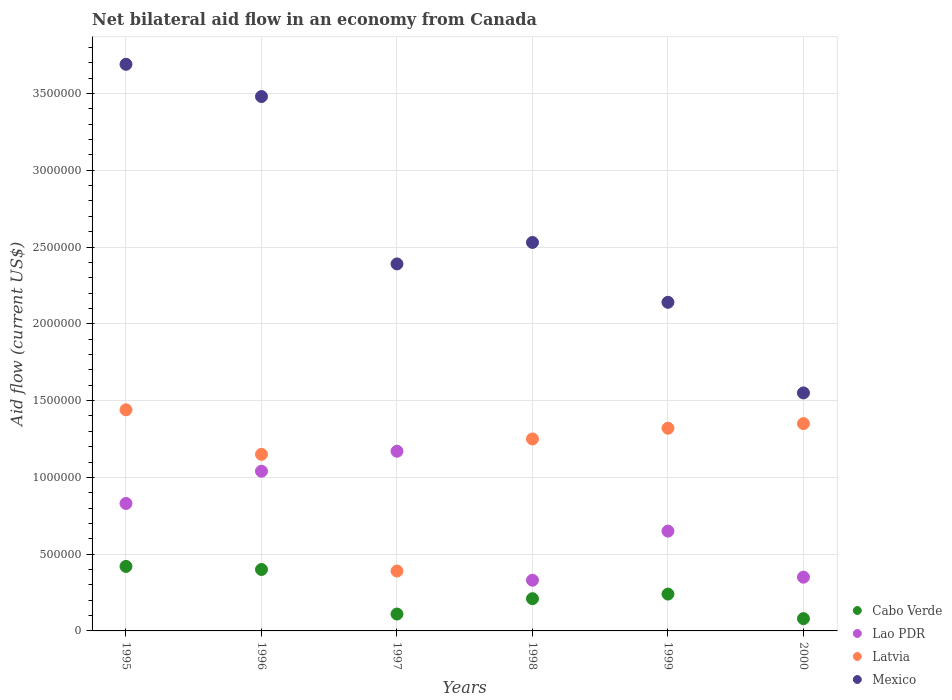How many different coloured dotlines are there?
Your answer should be very brief. 4. What is the net bilateral aid flow in Latvia in 1999?
Provide a short and direct response. 1.32e+06. Across all years, what is the maximum net bilateral aid flow in Latvia?
Give a very brief answer. 1.44e+06. What is the total net bilateral aid flow in Cabo Verde in the graph?
Your answer should be compact. 1.46e+06. What is the difference between the net bilateral aid flow in Latvia in 1996 and that in 1998?
Keep it short and to the point. -1.00e+05. What is the difference between the net bilateral aid flow in Mexico in 1995 and the net bilateral aid flow in Latvia in 2000?
Offer a terse response. 2.34e+06. What is the average net bilateral aid flow in Mexico per year?
Make the answer very short. 2.63e+06. In the year 1996, what is the difference between the net bilateral aid flow in Mexico and net bilateral aid flow in Cabo Verde?
Keep it short and to the point. 3.08e+06. In how many years, is the net bilateral aid flow in Mexico greater than 1300000 US$?
Provide a short and direct response. 6. What is the ratio of the net bilateral aid flow in Cabo Verde in 1997 to that in 1999?
Offer a terse response. 0.46. Is the net bilateral aid flow in Cabo Verde in 1997 less than that in 1999?
Keep it short and to the point. Yes. What is the difference between the highest and the second highest net bilateral aid flow in Mexico?
Give a very brief answer. 2.10e+05. What is the difference between the highest and the lowest net bilateral aid flow in Mexico?
Make the answer very short. 2.14e+06. Is the sum of the net bilateral aid flow in Cabo Verde in 1995 and 2000 greater than the maximum net bilateral aid flow in Lao PDR across all years?
Make the answer very short. No. Is it the case that in every year, the sum of the net bilateral aid flow in Latvia and net bilateral aid flow in Mexico  is greater than the net bilateral aid flow in Lao PDR?
Offer a very short reply. Yes. Does the net bilateral aid flow in Cabo Verde monotonically increase over the years?
Provide a succinct answer. No. Is the net bilateral aid flow in Cabo Verde strictly greater than the net bilateral aid flow in Mexico over the years?
Keep it short and to the point. No. How many dotlines are there?
Ensure brevity in your answer.  4. What is the difference between two consecutive major ticks on the Y-axis?
Provide a short and direct response. 5.00e+05. How many legend labels are there?
Give a very brief answer. 4. What is the title of the graph?
Give a very brief answer. Net bilateral aid flow in an economy from Canada. Does "Myanmar" appear as one of the legend labels in the graph?
Provide a short and direct response. No. What is the Aid flow (current US$) of Cabo Verde in 1995?
Ensure brevity in your answer.  4.20e+05. What is the Aid flow (current US$) of Lao PDR in 1995?
Your answer should be very brief. 8.30e+05. What is the Aid flow (current US$) of Latvia in 1995?
Provide a short and direct response. 1.44e+06. What is the Aid flow (current US$) in Mexico in 1995?
Your answer should be very brief. 3.69e+06. What is the Aid flow (current US$) of Cabo Verde in 1996?
Your response must be concise. 4.00e+05. What is the Aid flow (current US$) of Lao PDR in 1996?
Your response must be concise. 1.04e+06. What is the Aid flow (current US$) in Latvia in 1996?
Ensure brevity in your answer.  1.15e+06. What is the Aid flow (current US$) in Mexico in 1996?
Provide a succinct answer. 3.48e+06. What is the Aid flow (current US$) in Lao PDR in 1997?
Your response must be concise. 1.17e+06. What is the Aid flow (current US$) in Latvia in 1997?
Give a very brief answer. 3.90e+05. What is the Aid flow (current US$) of Mexico in 1997?
Your answer should be compact. 2.39e+06. What is the Aid flow (current US$) of Latvia in 1998?
Your answer should be very brief. 1.25e+06. What is the Aid flow (current US$) in Mexico in 1998?
Your answer should be very brief. 2.53e+06. What is the Aid flow (current US$) in Lao PDR in 1999?
Offer a very short reply. 6.50e+05. What is the Aid flow (current US$) of Latvia in 1999?
Provide a short and direct response. 1.32e+06. What is the Aid flow (current US$) in Mexico in 1999?
Offer a very short reply. 2.14e+06. What is the Aid flow (current US$) of Latvia in 2000?
Your answer should be compact. 1.35e+06. What is the Aid flow (current US$) of Mexico in 2000?
Your answer should be compact. 1.55e+06. Across all years, what is the maximum Aid flow (current US$) of Cabo Verde?
Your response must be concise. 4.20e+05. Across all years, what is the maximum Aid flow (current US$) of Lao PDR?
Provide a short and direct response. 1.17e+06. Across all years, what is the maximum Aid flow (current US$) of Latvia?
Keep it short and to the point. 1.44e+06. Across all years, what is the maximum Aid flow (current US$) of Mexico?
Offer a very short reply. 3.69e+06. Across all years, what is the minimum Aid flow (current US$) in Lao PDR?
Your response must be concise. 3.30e+05. Across all years, what is the minimum Aid flow (current US$) of Latvia?
Your answer should be very brief. 3.90e+05. Across all years, what is the minimum Aid flow (current US$) in Mexico?
Make the answer very short. 1.55e+06. What is the total Aid flow (current US$) of Cabo Verde in the graph?
Give a very brief answer. 1.46e+06. What is the total Aid flow (current US$) of Lao PDR in the graph?
Your answer should be compact. 4.37e+06. What is the total Aid flow (current US$) of Latvia in the graph?
Provide a succinct answer. 6.90e+06. What is the total Aid flow (current US$) of Mexico in the graph?
Your answer should be compact. 1.58e+07. What is the difference between the Aid flow (current US$) in Lao PDR in 1995 and that in 1996?
Provide a short and direct response. -2.10e+05. What is the difference between the Aid flow (current US$) in Latvia in 1995 and that in 1996?
Offer a terse response. 2.90e+05. What is the difference between the Aid flow (current US$) of Lao PDR in 1995 and that in 1997?
Keep it short and to the point. -3.40e+05. What is the difference between the Aid flow (current US$) of Latvia in 1995 and that in 1997?
Your answer should be very brief. 1.05e+06. What is the difference between the Aid flow (current US$) in Mexico in 1995 and that in 1997?
Your answer should be compact. 1.30e+06. What is the difference between the Aid flow (current US$) in Latvia in 1995 and that in 1998?
Ensure brevity in your answer.  1.90e+05. What is the difference between the Aid flow (current US$) of Mexico in 1995 and that in 1998?
Ensure brevity in your answer.  1.16e+06. What is the difference between the Aid flow (current US$) in Lao PDR in 1995 and that in 1999?
Keep it short and to the point. 1.80e+05. What is the difference between the Aid flow (current US$) of Latvia in 1995 and that in 1999?
Offer a terse response. 1.20e+05. What is the difference between the Aid flow (current US$) in Mexico in 1995 and that in 1999?
Make the answer very short. 1.55e+06. What is the difference between the Aid flow (current US$) of Cabo Verde in 1995 and that in 2000?
Offer a terse response. 3.40e+05. What is the difference between the Aid flow (current US$) of Latvia in 1995 and that in 2000?
Provide a succinct answer. 9.00e+04. What is the difference between the Aid flow (current US$) of Mexico in 1995 and that in 2000?
Offer a terse response. 2.14e+06. What is the difference between the Aid flow (current US$) in Lao PDR in 1996 and that in 1997?
Keep it short and to the point. -1.30e+05. What is the difference between the Aid flow (current US$) of Latvia in 1996 and that in 1997?
Offer a terse response. 7.60e+05. What is the difference between the Aid flow (current US$) of Mexico in 1996 and that in 1997?
Give a very brief answer. 1.09e+06. What is the difference between the Aid flow (current US$) in Cabo Verde in 1996 and that in 1998?
Provide a succinct answer. 1.90e+05. What is the difference between the Aid flow (current US$) in Lao PDR in 1996 and that in 1998?
Offer a very short reply. 7.10e+05. What is the difference between the Aid flow (current US$) of Latvia in 1996 and that in 1998?
Your response must be concise. -1.00e+05. What is the difference between the Aid flow (current US$) in Mexico in 1996 and that in 1998?
Offer a terse response. 9.50e+05. What is the difference between the Aid flow (current US$) of Cabo Verde in 1996 and that in 1999?
Offer a very short reply. 1.60e+05. What is the difference between the Aid flow (current US$) in Lao PDR in 1996 and that in 1999?
Ensure brevity in your answer.  3.90e+05. What is the difference between the Aid flow (current US$) of Mexico in 1996 and that in 1999?
Your response must be concise. 1.34e+06. What is the difference between the Aid flow (current US$) in Cabo Verde in 1996 and that in 2000?
Your answer should be compact. 3.20e+05. What is the difference between the Aid flow (current US$) in Lao PDR in 1996 and that in 2000?
Offer a terse response. 6.90e+05. What is the difference between the Aid flow (current US$) of Latvia in 1996 and that in 2000?
Ensure brevity in your answer.  -2.00e+05. What is the difference between the Aid flow (current US$) of Mexico in 1996 and that in 2000?
Make the answer very short. 1.93e+06. What is the difference between the Aid flow (current US$) in Lao PDR in 1997 and that in 1998?
Your answer should be very brief. 8.40e+05. What is the difference between the Aid flow (current US$) of Latvia in 1997 and that in 1998?
Your answer should be compact. -8.60e+05. What is the difference between the Aid flow (current US$) of Mexico in 1997 and that in 1998?
Provide a succinct answer. -1.40e+05. What is the difference between the Aid flow (current US$) in Lao PDR in 1997 and that in 1999?
Provide a short and direct response. 5.20e+05. What is the difference between the Aid flow (current US$) of Latvia in 1997 and that in 1999?
Provide a short and direct response. -9.30e+05. What is the difference between the Aid flow (current US$) in Cabo Verde in 1997 and that in 2000?
Ensure brevity in your answer.  3.00e+04. What is the difference between the Aid flow (current US$) in Lao PDR in 1997 and that in 2000?
Your response must be concise. 8.20e+05. What is the difference between the Aid flow (current US$) of Latvia in 1997 and that in 2000?
Offer a terse response. -9.60e+05. What is the difference between the Aid flow (current US$) in Mexico in 1997 and that in 2000?
Your answer should be very brief. 8.40e+05. What is the difference between the Aid flow (current US$) in Lao PDR in 1998 and that in 1999?
Your answer should be very brief. -3.20e+05. What is the difference between the Aid flow (current US$) in Latvia in 1998 and that in 1999?
Offer a very short reply. -7.00e+04. What is the difference between the Aid flow (current US$) in Mexico in 1998 and that in 1999?
Keep it short and to the point. 3.90e+05. What is the difference between the Aid flow (current US$) in Cabo Verde in 1998 and that in 2000?
Ensure brevity in your answer.  1.30e+05. What is the difference between the Aid flow (current US$) of Mexico in 1998 and that in 2000?
Provide a succinct answer. 9.80e+05. What is the difference between the Aid flow (current US$) in Mexico in 1999 and that in 2000?
Offer a very short reply. 5.90e+05. What is the difference between the Aid flow (current US$) in Cabo Verde in 1995 and the Aid flow (current US$) in Lao PDR in 1996?
Make the answer very short. -6.20e+05. What is the difference between the Aid flow (current US$) in Cabo Verde in 1995 and the Aid flow (current US$) in Latvia in 1996?
Offer a very short reply. -7.30e+05. What is the difference between the Aid flow (current US$) of Cabo Verde in 1995 and the Aid flow (current US$) of Mexico in 1996?
Your answer should be very brief. -3.06e+06. What is the difference between the Aid flow (current US$) of Lao PDR in 1995 and the Aid flow (current US$) of Latvia in 1996?
Ensure brevity in your answer.  -3.20e+05. What is the difference between the Aid flow (current US$) of Lao PDR in 1995 and the Aid flow (current US$) of Mexico in 1996?
Your answer should be compact. -2.65e+06. What is the difference between the Aid flow (current US$) in Latvia in 1995 and the Aid flow (current US$) in Mexico in 1996?
Provide a short and direct response. -2.04e+06. What is the difference between the Aid flow (current US$) of Cabo Verde in 1995 and the Aid flow (current US$) of Lao PDR in 1997?
Your answer should be compact. -7.50e+05. What is the difference between the Aid flow (current US$) in Cabo Verde in 1995 and the Aid flow (current US$) in Mexico in 1997?
Make the answer very short. -1.97e+06. What is the difference between the Aid flow (current US$) of Lao PDR in 1995 and the Aid flow (current US$) of Latvia in 1997?
Offer a terse response. 4.40e+05. What is the difference between the Aid flow (current US$) of Lao PDR in 1995 and the Aid flow (current US$) of Mexico in 1997?
Offer a very short reply. -1.56e+06. What is the difference between the Aid flow (current US$) of Latvia in 1995 and the Aid flow (current US$) of Mexico in 1997?
Give a very brief answer. -9.50e+05. What is the difference between the Aid flow (current US$) in Cabo Verde in 1995 and the Aid flow (current US$) in Lao PDR in 1998?
Offer a very short reply. 9.00e+04. What is the difference between the Aid flow (current US$) in Cabo Verde in 1995 and the Aid flow (current US$) in Latvia in 1998?
Provide a short and direct response. -8.30e+05. What is the difference between the Aid flow (current US$) of Cabo Verde in 1995 and the Aid flow (current US$) of Mexico in 1998?
Your response must be concise. -2.11e+06. What is the difference between the Aid flow (current US$) in Lao PDR in 1995 and the Aid flow (current US$) in Latvia in 1998?
Provide a short and direct response. -4.20e+05. What is the difference between the Aid flow (current US$) of Lao PDR in 1995 and the Aid flow (current US$) of Mexico in 1998?
Offer a terse response. -1.70e+06. What is the difference between the Aid flow (current US$) in Latvia in 1995 and the Aid flow (current US$) in Mexico in 1998?
Give a very brief answer. -1.09e+06. What is the difference between the Aid flow (current US$) in Cabo Verde in 1995 and the Aid flow (current US$) in Latvia in 1999?
Your answer should be very brief. -9.00e+05. What is the difference between the Aid flow (current US$) in Cabo Verde in 1995 and the Aid flow (current US$) in Mexico in 1999?
Offer a terse response. -1.72e+06. What is the difference between the Aid flow (current US$) in Lao PDR in 1995 and the Aid flow (current US$) in Latvia in 1999?
Offer a terse response. -4.90e+05. What is the difference between the Aid flow (current US$) in Lao PDR in 1995 and the Aid flow (current US$) in Mexico in 1999?
Your answer should be compact. -1.31e+06. What is the difference between the Aid flow (current US$) of Latvia in 1995 and the Aid flow (current US$) of Mexico in 1999?
Your response must be concise. -7.00e+05. What is the difference between the Aid flow (current US$) in Cabo Verde in 1995 and the Aid flow (current US$) in Lao PDR in 2000?
Your response must be concise. 7.00e+04. What is the difference between the Aid flow (current US$) in Cabo Verde in 1995 and the Aid flow (current US$) in Latvia in 2000?
Your answer should be compact. -9.30e+05. What is the difference between the Aid flow (current US$) in Cabo Verde in 1995 and the Aid flow (current US$) in Mexico in 2000?
Provide a succinct answer. -1.13e+06. What is the difference between the Aid flow (current US$) in Lao PDR in 1995 and the Aid flow (current US$) in Latvia in 2000?
Provide a short and direct response. -5.20e+05. What is the difference between the Aid flow (current US$) in Lao PDR in 1995 and the Aid flow (current US$) in Mexico in 2000?
Your answer should be very brief. -7.20e+05. What is the difference between the Aid flow (current US$) in Latvia in 1995 and the Aid flow (current US$) in Mexico in 2000?
Provide a succinct answer. -1.10e+05. What is the difference between the Aid flow (current US$) of Cabo Verde in 1996 and the Aid flow (current US$) of Lao PDR in 1997?
Your response must be concise. -7.70e+05. What is the difference between the Aid flow (current US$) of Cabo Verde in 1996 and the Aid flow (current US$) of Mexico in 1997?
Your answer should be very brief. -1.99e+06. What is the difference between the Aid flow (current US$) of Lao PDR in 1996 and the Aid flow (current US$) of Latvia in 1997?
Provide a succinct answer. 6.50e+05. What is the difference between the Aid flow (current US$) in Lao PDR in 1996 and the Aid flow (current US$) in Mexico in 1997?
Give a very brief answer. -1.35e+06. What is the difference between the Aid flow (current US$) of Latvia in 1996 and the Aid flow (current US$) of Mexico in 1997?
Provide a short and direct response. -1.24e+06. What is the difference between the Aid flow (current US$) of Cabo Verde in 1996 and the Aid flow (current US$) of Lao PDR in 1998?
Provide a succinct answer. 7.00e+04. What is the difference between the Aid flow (current US$) in Cabo Verde in 1996 and the Aid flow (current US$) in Latvia in 1998?
Provide a short and direct response. -8.50e+05. What is the difference between the Aid flow (current US$) of Cabo Verde in 1996 and the Aid flow (current US$) of Mexico in 1998?
Your answer should be compact. -2.13e+06. What is the difference between the Aid flow (current US$) of Lao PDR in 1996 and the Aid flow (current US$) of Latvia in 1998?
Your answer should be compact. -2.10e+05. What is the difference between the Aid flow (current US$) of Lao PDR in 1996 and the Aid flow (current US$) of Mexico in 1998?
Your answer should be compact. -1.49e+06. What is the difference between the Aid flow (current US$) in Latvia in 1996 and the Aid flow (current US$) in Mexico in 1998?
Offer a terse response. -1.38e+06. What is the difference between the Aid flow (current US$) of Cabo Verde in 1996 and the Aid flow (current US$) of Lao PDR in 1999?
Offer a terse response. -2.50e+05. What is the difference between the Aid flow (current US$) in Cabo Verde in 1996 and the Aid flow (current US$) in Latvia in 1999?
Your answer should be very brief. -9.20e+05. What is the difference between the Aid flow (current US$) in Cabo Verde in 1996 and the Aid flow (current US$) in Mexico in 1999?
Make the answer very short. -1.74e+06. What is the difference between the Aid flow (current US$) of Lao PDR in 1996 and the Aid flow (current US$) of Latvia in 1999?
Offer a very short reply. -2.80e+05. What is the difference between the Aid flow (current US$) in Lao PDR in 1996 and the Aid flow (current US$) in Mexico in 1999?
Offer a very short reply. -1.10e+06. What is the difference between the Aid flow (current US$) in Latvia in 1996 and the Aid flow (current US$) in Mexico in 1999?
Your response must be concise. -9.90e+05. What is the difference between the Aid flow (current US$) of Cabo Verde in 1996 and the Aid flow (current US$) of Lao PDR in 2000?
Provide a succinct answer. 5.00e+04. What is the difference between the Aid flow (current US$) of Cabo Verde in 1996 and the Aid flow (current US$) of Latvia in 2000?
Offer a very short reply. -9.50e+05. What is the difference between the Aid flow (current US$) in Cabo Verde in 1996 and the Aid flow (current US$) in Mexico in 2000?
Keep it short and to the point. -1.15e+06. What is the difference between the Aid flow (current US$) in Lao PDR in 1996 and the Aid flow (current US$) in Latvia in 2000?
Your answer should be very brief. -3.10e+05. What is the difference between the Aid flow (current US$) in Lao PDR in 1996 and the Aid flow (current US$) in Mexico in 2000?
Your response must be concise. -5.10e+05. What is the difference between the Aid flow (current US$) in Latvia in 1996 and the Aid flow (current US$) in Mexico in 2000?
Offer a very short reply. -4.00e+05. What is the difference between the Aid flow (current US$) of Cabo Verde in 1997 and the Aid flow (current US$) of Latvia in 1998?
Make the answer very short. -1.14e+06. What is the difference between the Aid flow (current US$) in Cabo Verde in 1997 and the Aid flow (current US$) in Mexico in 1998?
Keep it short and to the point. -2.42e+06. What is the difference between the Aid flow (current US$) of Lao PDR in 1997 and the Aid flow (current US$) of Mexico in 1998?
Give a very brief answer. -1.36e+06. What is the difference between the Aid flow (current US$) of Latvia in 1997 and the Aid flow (current US$) of Mexico in 1998?
Provide a succinct answer. -2.14e+06. What is the difference between the Aid flow (current US$) in Cabo Verde in 1997 and the Aid flow (current US$) in Lao PDR in 1999?
Provide a succinct answer. -5.40e+05. What is the difference between the Aid flow (current US$) in Cabo Verde in 1997 and the Aid flow (current US$) in Latvia in 1999?
Offer a terse response. -1.21e+06. What is the difference between the Aid flow (current US$) in Cabo Verde in 1997 and the Aid flow (current US$) in Mexico in 1999?
Give a very brief answer. -2.03e+06. What is the difference between the Aid flow (current US$) in Lao PDR in 1997 and the Aid flow (current US$) in Latvia in 1999?
Your answer should be compact. -1.50e+05. What is the difference between the Aid flow (current US$) of Lao PDR in 1997 and the Aid flow (current US$) of Mexico in 1999?
Keep it short and to the point. -9.70e+05. What is the difference between the Aid flow (current US$) of Latvia in 1997 and the Aid flow (current US$) of Mexico in 1999?
Your answer should be very brief. -1.75e+06. What is the difference between the Aid flow (current US$) of Cabo Verde in 1997 and the Aid flow (current US$) of Latvia in 2000?
Your answer should be very brief. -1.24e+06. What is the difference between the Aid flow (current US$) of Cabo Verde in 1997 and the Aid flow (current US$) of Mexico in 2000?
Ensure brevity in your answer.  -1.44e+06. What is the difference between the Aid flow (current US$) in Lao PDR in 1997 and the Aid flow (current US$) in Latvia in 2000?
Your response must be concise. -1.80e+05. What is the difference between the Aid flow (current US$) of Lao PDR in 1997 and the Aid flow (current US$) of Mexico in 2000?
Offer a terse response. -3.80e+05. What is the difference between the Aid flow (current US$) in Latvia in 1997 and the Aid flow (current US$) in Mexico in 2000?
Offer a very short reply. -1.16e+06. What is the difference between the Aid flow (current US$) of Cabo Verde in 1998 and the Aid flow (current US$) of Lao PDR in 1999?
Make the answer very short. -4.40e+05. What is the difference between the Aid flow (current US$) of Cabo Verde in 1998 and the Aid flow (current US$) of Latvia in 1999?
Offer a very short reply. -1.11e+06. What is the difference between the Aid flow (current US$) of Cabo Verde in 1998 and the Aid flow (current US$) of Mexico in 1999?
Give a very brief answer. -1.93e+06. What is the difference between the Aid flow (current US$) in Lao PDR in 1998 and the Aid flow (current US$) in Latvia in 1999?
Your answer should be compact. -9.90e+05. What is the difference between the Aid flow (current US$) in Lao PDR in 1998 and the Aid flow (current US$) in Mexico in 1999?
Your response must be concise. -1.81e+06. What is the difference between the Aid flow (current US$) in Latvia in 1998 and the Aid flow (current US$) in Mexico in 1999?
Ensure brevity in your answer.  -8.90e+05. What is the difference between the Aid flow (current US$) in Cabo Verde in 1998 and the Aid flow (current US$) in Latvia in 2000?
Your answer should be very brief. -1.14e+06. What is the difference between the Aid flow (current US$) of Cabo Verde in 1998 and the Aid flow (current US$) of Mexico in 2000?
Your answer should be very brief. -1.34e+06. What is the difference between the Aid flow (current US$) in Lao PDR in 1998 and the Aid flow (current US$) in Latvia in 2000?
Your response must be concise. -1.02e+06. What is the difference between the Aid flow (current US$) of Lao PDR in 1998 and the Aid flow (current US$) of Mexico in 2000?
Offer a terse response. -1.22e+06. What is the difference between the Aid flow (current US$) of Cabo Verde in 1999 and the Aid flow (current US$) of Lao PDR in 2000?
Provide a succinct answer. -1.10e+05. What is the difference between the Aid flow (current US$) of Cabo Verde in 1999 and the Aid flow (current US$) of Latvia in 2000?
Ensure brevity in your answer.  -1.11e+06. What is the difference between the Aid flow (current US$) of Cabo Verde in 1999 and the Aid flow (current US$) of Mexico in 2000?
Offer a terse response. -1.31e+06. What is the difference between the Aid flow (current US$) in Lao PDR in 1999 and the Aid flow (current US$) in Latvia in 2000?
Provide a succinct answer. -7.00e+05. What is the difference between the Aid flow (current US$) of Lao PDR in 1999 and the Aid flow (current US$) of Mexico in 2000?
Provide a short and direct response. -9.00e+05. What is the average Aid flow (current US$) in Cabo Verde per year?
Keep it short and to the point. 2.43e+05. What is the average Aid flow (current US$) of Lao PDR per year?
Keep it short and to the point. 7.28e+05. What is the average Aid flow (current US$) of Latvia per year?
Your answer should be compact. 1.15e+06. What is the average Aid flow (current US$) in Mexico per year?
Your answer should be very brief. 2.63e+06. In the year 1995, what is the difference between the Aid flow (current US$) of Cabo Verde and Aid flow (current US$) of Lao PDR?
Your answer should be compact. -4.10e+05. In the year 1995, what is the difference between the Aid flow (current US$) of Cabo Verde and Aid flow (current US$) of Latvia?
Your answer should be very brief. -1.02e+06. In the year 1995, what is the difference between the Aid flow (current US$) of Cabo Verde and Aid flow (current US$) of Mexico?
Your answer should be very brief. -3.27e+06. In the year 1995, what is the difference between the Aid flow (current US$) in Lao PDR and Aid flow (current US$) in Latvia?
Make the answer very short. -6.10e+05. In the year 1995, what is the difference between the Aid flow (current US$) of Lao PDR and Aid flow (current US$) of Mexico?
Provide a short and direct response. -2.86e+06. In the year 1995, what is the difference between the Aid flow (current US$) in Latvia and Aid flow (current US$) in Mexico?
Provide a succinct answer. -2.25e+06. In the year 1996, what is the difference between the Aid flow (current US$) of Cabo Verde and Aid flow (current US$) of Lao PDR?
Give a very brief answer. -6.40e+05. In the year 1996, what is the difference between the Aid flow (current US$) of Cabo Verde and Aid flow (current US$) of Latvia?
Give a very brief answer. -7.50e+05. In the year 1996, what is the difference between the Aid flow (current US$) in Cabo Verde and Aid flow (current US$) in Mexico?
Ensure brevity in your answer.  -3.08e+06. In the year 1996, what is the difference between the Aid flow (current US$) in Lao PDR and Aid flow (current US$) in Mexico?
Ensure brevity in your answer.  -2.44e+06. In the year 1996, what is the difference between the Aid flow (current US$) of Latvia and Aid flow (current US$) of Mexico?
Your answer should be compact. -2.33e+06. In the year 1997, what is the difference between the Aid flow (current US$) in Cabo Verde and Aid flow (current US$) in Lao PDR?
Offer a terse response. -1.06e+06. In the year 1997, what is the difference between the Aid flow (current US$) in Cabo Verde and Aid flow (current US$) in Latvia?
Your answer should be very brief. -2.80e+05. In the year 1997, what is the difference between the Aid flow (current US$) of Cabo Verde and Aid flow (current US$) of Mexico?
Keep it short and to the point. -2.28e+06. In the year 1997, what is the difference between the Aid flow (current US$) in Lao PDR and Aid flow (current US$) in Latvia?
Ensure brevity in your answer.  7.80e+05. In the year 1997, what is the difference between the Aid flow (current US$) of Lao PDR and Aid flow (current US$) of Mexico?
Provide a succinct answer. -1.22e+06. In the year 1998, what is the difference between the Aid flow (current US$) of Cabo Verde and Aid flow (current US$) of Lao PDR?
Offer a very short reply. -1.20e+05. In the year 1998, what is the difference between the Aid flow (current US$) in Cabo Verde and Aid flow (current US$) in Latvia?
Provide a succinct answer. -1.04e+06. In the year 1998, what is the difference between the Aid flow (current US$) in Cabo Verde and Aid flow (current US$) in Mexico?
Your response must be concise. -2.32e+06. In the year 1998, what is the difference between the Aid flow (current US$) in Lao PDR and Aid flow (current US$) in Latvia?
Ensure brevity in your answer.  -9.20e+05. In the year 1998, what is the difference between the Aid flow (current US$) in Lao PDR and Aid flow (current US$) in Mexico?
Your answer should be compact. -2.20e+06. In the year 1998, what is the difference between the Aid flow (current US$) of Latvia and Aid flow (current US$) of Mexico?
Offer a very short reply. -1.28e+06. In the year 1999, what is the difference between the Aid flow (current US$) in Cabo Verde and Aid flow (current US$) in Lao PDR?
Offer a very short reply. -4.10e+05. In the year 1999, what is the difference between the Aid flow (current US$) in Cabo Verde and Aid flow (current US$) in Latvia?
Provide a short and direct response. -1.08e+06. In the year 1999, what is the difference between the Aid flow (current US$) in Cabo Verde and Aid flow (current US$) in Mexico?
Offer a very short reply. -1.90e+06. In the year 1999, what is the difference between the Aid flow (current US$) of Lao PDR and Aid flow (current US$) of Latvia?
Make the answer very short. -6.70e+05. In the year 1999, what is the difference between the Aid flow (current US$) of Lao PDR and Aid flow (current US$) of Mexico?
Provide a succinct answer. -1.49e+06. In the year 1999, what is the difference between the Aid flow (current US$) in Latvia and Aid flow (current US$) in Mexico?
Offer a terse response. -8.20e+05. In the year 2000, what is the difference between the Aid flow (current US$) in Cabo Verde and Aid flow (current US$) in Latvia?
Offer a very short reply. -1.27e+06. In the year 2000, what is the difference between the Aid flow (current US$) of Cabo Verde and Aid flow (current US$) of Mexico?
Ensure brevity in your answer.  -1.47e+06. In the year 2000, what is the difference between the Aid flow (current US$) of Lao PDR and Aid flow (current US$) of Latvia?
Give a very brief answer. -1.00e+06. In the year 2000, what is the difference between the Aid flow (current US$) of Lao PDR and Aid flow (current US$) of Mexico?
Ensure brevity in your answer.  -1.20e+06. In the year 2000, what is the difference between the Aid flow (current US$) in Latvia and Aid flow (current US$) in Mexico?
Offer a very short reply. -2.00e+05. What is the ratio of the Aid flow (current US$) of Cabo Verde in 1995 to that in 1996?
Make the answer very short. 1.05. What is the ratio of the Aid flow (current US$) in Lao PDR in 1995 to that in 1996?
Provide a short and direct response. 0.8. What is the ratio of the Aid flow (current US$) in Latvia in 1995 to that in 1996?
Provide a succinct answer. 1.25. What is the ratio of the Aid flow (current US$) of Mexico in 1995 to that in 1996?
Offer a very short reply. 1.06. What is the ratio of the Aid flow (current US$) of Cabo Verde in 1995 to that in 1997?
Your response must be concise. 3.82. What is the ratio of the Aid flow (current US$) in Lao PDR in 1995 to that in 1997?
Provide a succinct answer. 0.71. What is the ratio of the Aid flow (current US$) of Latvia in 1995 to that in 1997?
Your response must be concise. 3.69. What is the ratio of the Aid flow (current US$) in Mexico in 1995 to that in 1997?
Offer a very short reply. 1.54. What is the ratio of the Aid flow (current US$) in Cabo Verde in 1995 to that in 1998?
Provide a short and direct response. 2. What is the ratio of the Aid flow (current US$) of Lao PDR in 1995 to that in 1998?
Provide a succinct answer. 2.52. What is the ratio of the Aid flow (current US$) in Latvia in 1995 to that in 1998?
Keep it short and to the point. 1.15. What is the ratio of the Aid flow (current US$) of Mexico in 1995 to that in 1998?
Provide a short and direct response. 1.46. What is the ratio of the Aid flow (current US$) of Cabo Verde in 1995 to that in 1999?
Your answer should be very brief. 1.75. What is the ratio of the Aid flow (current US$) in Lao PDR in 1995 to that in 1999?
Your response must be concise. 1.28. What is the ratio of the Aid flow (current US$) of Latvia in 1995 to that in 1999?
Keep it short and to the point. 1.09. What is the ratio of the Aid flow (current US$) in Mexico in 1995 to that in 1999?
Provide a short and direct response. 1.72. What is the ratio of the Aid flow (current US$) in Cabo Verde in 1995 to that in 2000?
Provide a succinct answer. 5.25. What is the ratio of the Aid flow (current US$) of Lao PDR in 1995 to that in 2000?
Provide a succinct answer. 2.37. What is the ratio of the Aid flow (current US$) in Latvia in 1995 to that in 2000?
Offer a terse response. 1.07. What is the ratio of the Aid flow (current US$) in Mexico in 1995 to that in 2000?
Your answer should be compact. 2.38. What is the ratio of the Aid flow (current US$) in Cabo Verde in 1996 to that in 1997?
Offer a very short reply. 3.64. What is the ratio of the Aid flow (current US$) in Lao PDR in 1996 to that in 1997?
Your response must be concise. 0.89. What is the ratio of the Aid flow (current US$) of Latvia in 1996 to that in 1997?
Your response must be concise. 2.95. What is the ratio of the Aid flow (current US$) in Mexico in 1996 to that in 1997?
Provide a short and direct response. 1.46. What is the ratio of the Aid flow (current US$) of Cabo Verde in 1996 to that in 1998?
Offer a very short reply. 1.9. What is the ratio of the Aid flow (current US$) in Lao PDR in 1996 to that in 1998?
Give a very brief answer. 3.15. What is the ratio of the Aid flow (current US$) in Mexico in 1996 to that in 1998?
Give a very brief answer. 1.38. What is the ratio of the Aid flow (current US$) in Cabo Verde in 1996 to that in 1999?
Your response must be concise. 1.67. What is the ratio of the Aid flow (current US$) in Latvia in 1996 to that in 1999?
Ensure brevity in your answer.  0.87. What is the ratio of the Aid flow (current US$) of Mexico in 1996 to that in 1999?
Make the answer very short. 1.63. What is the ratio of the Aid flow (current US$) of Cabo Verde in 1996 to that in 2000?
Provide a succinct answer. 5. What is the ratio of the Aid flow (current US$) of Lao PDR in 1996 to that in 2000?
Your answer should be very brief. 2.97. What is the ratio of the Aid flow (current US$) of Latvia in 1996 to that in 2000?
Provide a succinct answer. 0.85. What is the ratio of the Aid flow (current US$) of Mexico in 1996 to that in 2000?
Your answer should be compact. 2.25. What is the ratio of the Aid flow (current US$) of Cabo Verde in 1997 to that in 1998?
Provide a short and direct response. 0.52. What is the ratio of the Aid flow (current US$) of Lao PDR in 1997 to that in 1998?
Keep it short and to the point. 3.55. What is the ratio of the Aid flow (current US$) of Latvia in 1997 to that in 1998?
Keep it short and to the point. 0.31. What is the ratio of the Aid flow (current US$) of Mexico in 1997 to that in 1998?
Your answer should be very brief. 0.94. What is the ratio of the Aid flow (current US$) in Cabo Verde in 1997 to that in 1999?
Your answer should be very brief. 0.46. What is the ratio of the Aid flow (current US$) in Latvia in 1997 to that in 1999?
Your answer should be very brief. 0.3. What is the ratio of the Aid flow (current US$) in Mexico in 1997 to that in 1999?
Offer a very short reply. 1.12. What is the ratio of the Aid flow (current US$) in Cabo Verde in 1997 to that in 2000?
Keep it short and to the point. 1.38. What is the ratio of the Aid flow (current US$) of Lao PDR in 1997 to that in 2000?
Your response must be concise. 3.34. What is the ratio of the Aid flow (current US$) of Latvia in 1997 to that in 2000?
Offer a terse response. 0.29. What is the ratio of the Aid flow (current US$) in Mexico in 1997 to that in 2000?
Offer a terse response. 1.54. What is the ratio of the Aid flow (current US$) in Cabo Verde in 1998 to that in 1999?
Make the answer very short. 0.88. What is the ratio of the Aid flow (current US$) in Lao PDR in 1998 to that in 1999?
Ensure brevity in your answer.  0.51. What is the ratio of the Aid flow (current US$) of Latvia in 1998 to that in 1999?
Keep it short and to the point. 0.95. What is the ratio of the Aid flow (current US$) in Mexico in 1998 to that in 1999?
Ensure brevity in your answer.  1.18. What is the ratio of the Aid flow (current US$) of Cabo Verde in 1998 to that in 2000?
Your answer should be very brief. 2.62. What is the ratio of the Aid flow (current US$) in Lao PDR in 1998 to that in 2000?
Offer a terse response. 0.94. What is the ratio of the Aid flow (current US$) of Latvia in 1998 to that in 2000?
Your answer should be very brief. 0.93. What is the ratio of the Aid flow (current US$) in Mexico in 1998 to that in 2000?
Offer a terse response. 1.63. What is the ratio of the Aid flow (current US$) in Lao PDR in 1999 to that in 2000?
Give a very brief answer. 1.86. What is the ratio of the Aid flow (current US$) of Latvia in 1999 to that in 2000?
Keep it short and to the point. 0.98. What is the ratio of the Aid flow (current US$) in Mexico in 1999 to that in 2000?
Make the answer very short. 1.38. What is the difference between the highest and the second highest Aid flow (current US$) in Cabo Verde?
Your answer should be compact. 2.00e+04. What is the difference between the highest and the second highest Aid flow (current US$) in Lao PDR?
Offer a terse response. 1.30e+05. What is the difference between the highest and the second highest Aid flow (current US$) in Latvia?
Ensure brevity in your answer.  9.00e+04. What is the difference between the highest and the lowest Aid flow (current US$) of Lao PDR?
Give a very brief answer. 8.40e+05. What is the difference between the highest and the lowest Aid flow (current US$) in Latvia?
Ensure brevity in your answer.  1.05e+06. What is the difference between the highest and the lowest Aid flow (current US$) in Mexico?
Your answer should be very brief. 2.14e+06. 